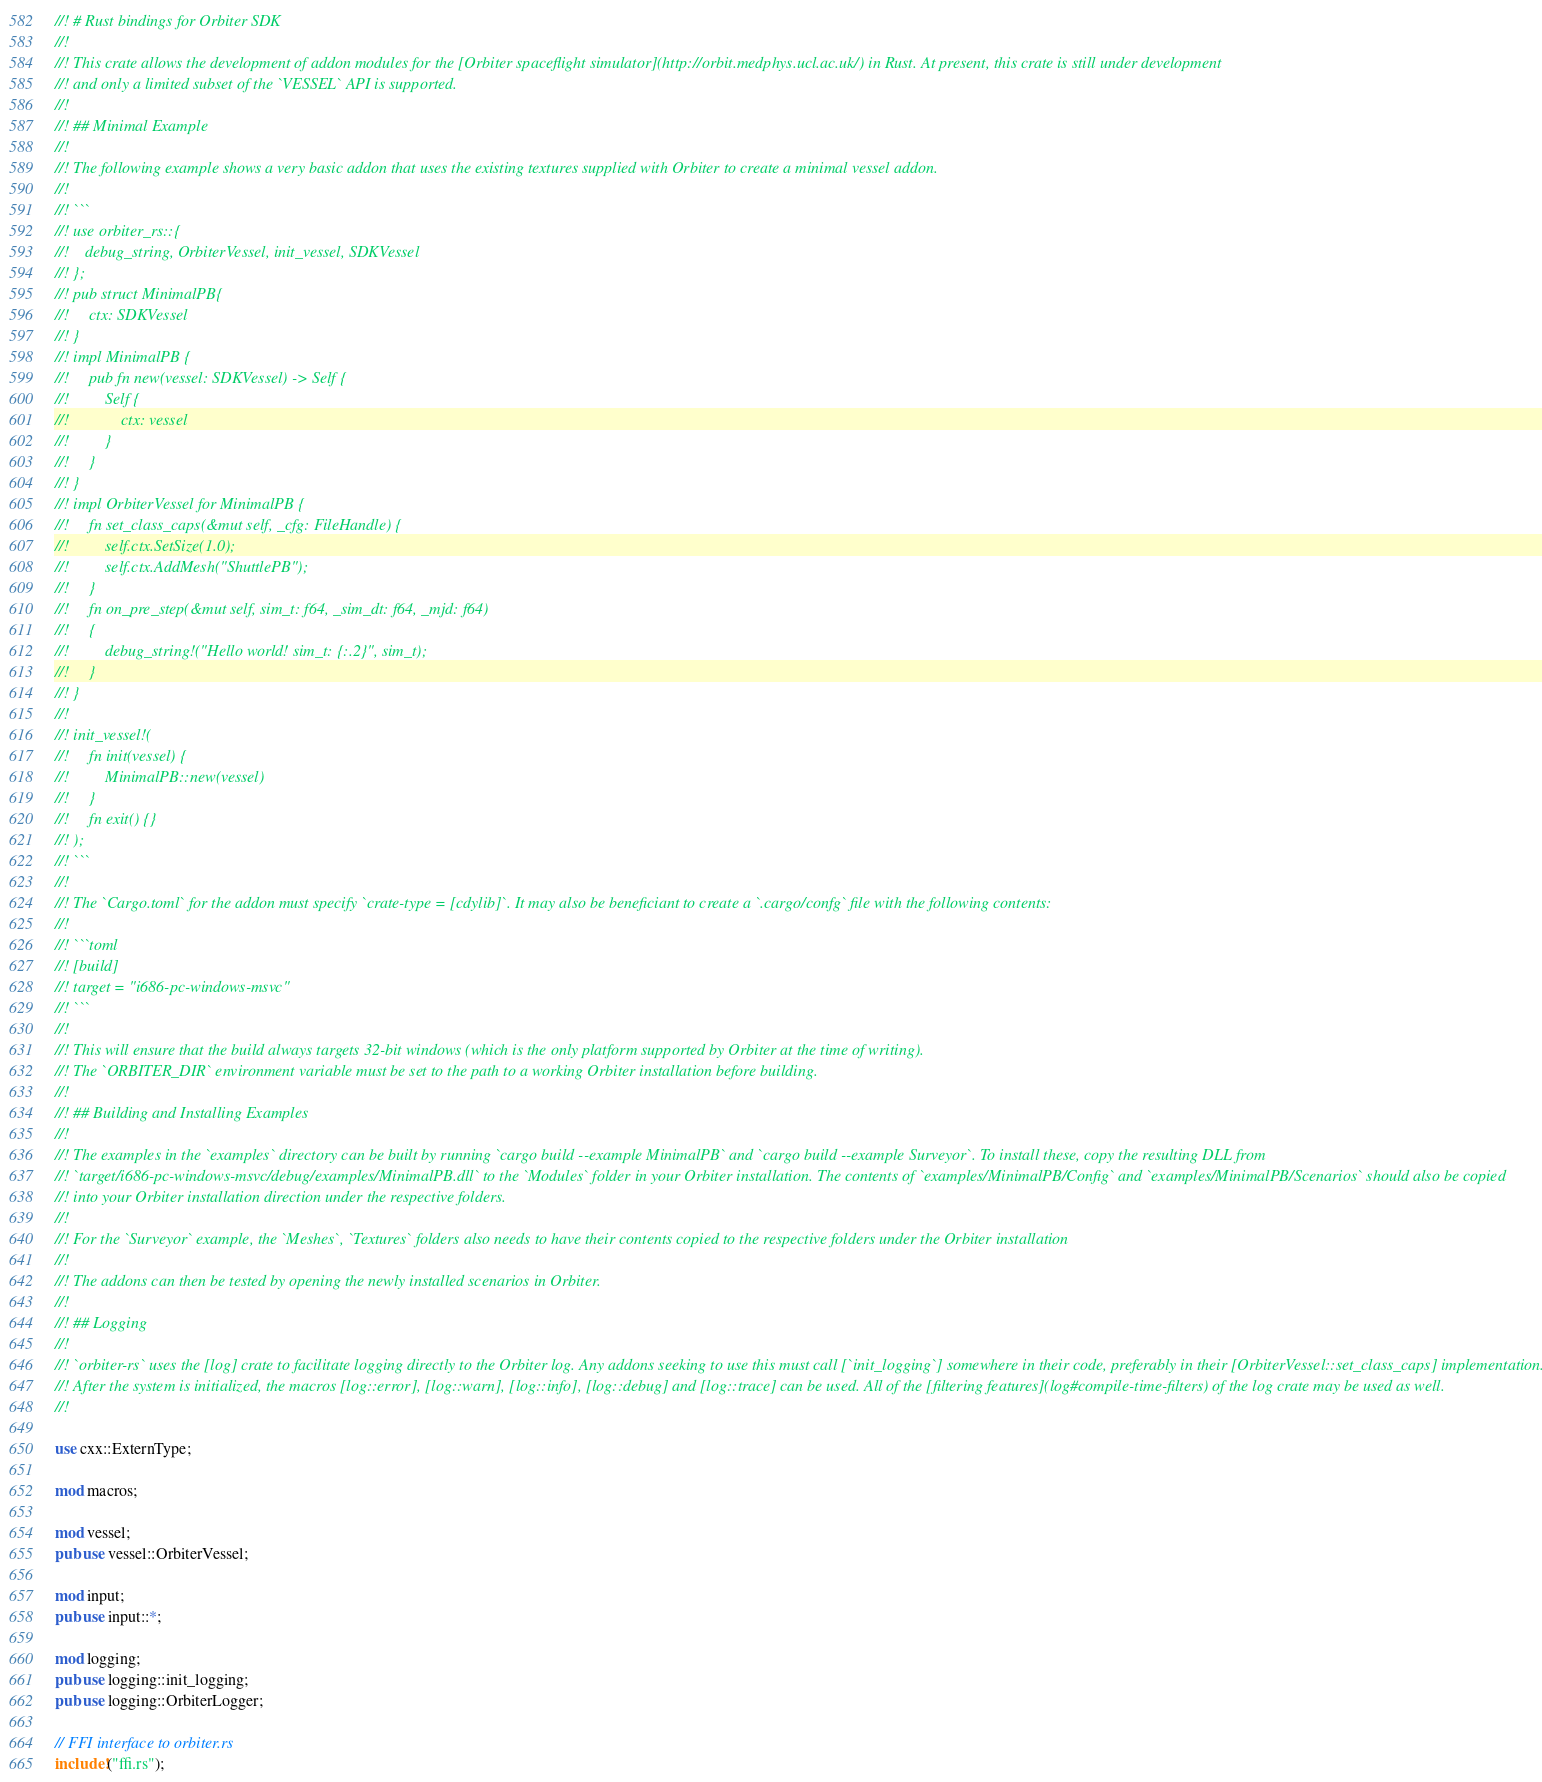<code> <loc_0><loc_0><loc_500><loc_500><_Rust_>//! # Rust bindings for Orbiter SDK
//!  
//! This crate allows the development of addon modules for the [Orbiter spaceflight simulator](http://orbit.medphys.ucl.ac.uk/) in Rust. At present, this crate is still under development
//! and only a limited subset of the `VESSEL` API is supported.
//!
//! ## Minimal Example
//!
//! The following example shows a very basic addon that uses the existing textures supplied with Orbiter to create a minimal vessel addon.
//!
//! ```
//! use orbiter_rs::{
//!    debug_string, OrbiterVessel, init_vessel, SDKVessel
//! };
//! pub struct MinimalPB{
//!     ctx: SDKVessel
//! }
//! impl MinimalPB {
//!     pub fn new(vessel: SDKVessel) -> Self {
//!         Self {
//!             ctx: vessel
//!         }
//!     }
//! }
//! impl OrbiterVessel for MinimalPB {
//!     fn set_class_caps(&mut self, _cfg: FileHandle) {
//!         self.ctx.SetSize(1.0);
//!         self.ctx.AddMesh("ShuttlePB");
//!     }
//!     fn on_pre_step(&mut self, sim_t: f64, _sim_dt: f64, _mjd: f64)
//!     {
//!         debug_string!("Hello world! sim_t: {:.2}", sim_t);
//!     }
//! }
//!
//! init_vessel!(
//!     fn init(vessel) {
//!         MinimalPB::new(vessel)
//!     }
//!     fn exit() {}
//! );
//! ```
//!
//! The `Cargo.toml` for the addon must specify `crate-type = [cdylib]`. It may also be beneficiant to create a `.cargo/confg` file with the following contents:
//!
//! ```toml
//! [build]
//! target = "i686-pc-windows-msvc"
//! ```
//!
//! This will ensure that the build always targets 32-bit windows (which is the only platform supported by Orbiter at the time of writing).
//! The `ORBITER_DIR` environment variable must be set to the path to a working Orbiter installation before building.
//!
//! ## Building and Installing Examples
//!
//! The examples in the `examples` directory can be built by running `cargo build --example MinimalPB` and `cargo build --example Surveyor`. To install these, copy the resulting DLL from
//! `target/i686-pc-windows-msvc/debug/examples/MinimalPB.dll` to the `Modules` folder in your Orbiter installation. The contents of `examples/MinimalPB/Config` and `examples/MinimalPB/Scenarios` should also be copied
//! into your Orbiter installation direction under the respective folders.
//!
//! For the `Surveyor` example, the `Meshes`, `Textures` folders also needs to have their contents copied to the respective folders under the Orbiter installation
//!
//! The addons can then be tested by opening the newly installed scenarios in Orbiter.
//!
//! ## Logging
//!
//! `orbiter-rs` uses the [log] crate to facilitate logging directly to the Orbiter log. Any addons seeking to use this must call [`init_logging`] somewhere in their code, preferably in their [OrbiterVessel::set_class_caps] implementation.
//! After the system is initialized, the macros [log::error], [log::warn], [log::info], [log::debug] and [log::trace] can be used. All of the [filtering features](log#compile-time-filters) of the log crate may be used as well.
//!

use cxx::ExternType;

mod macros;

mod vessel;
pub use vessel::OrbiterVessel;

mod input;
pub use input::*;

mod logging;
pub use logging::init_logging;
pub use logging::OrbiterLogger;

// FFI interface to orbiter.rs
include!("ffi.rs");
</code> 